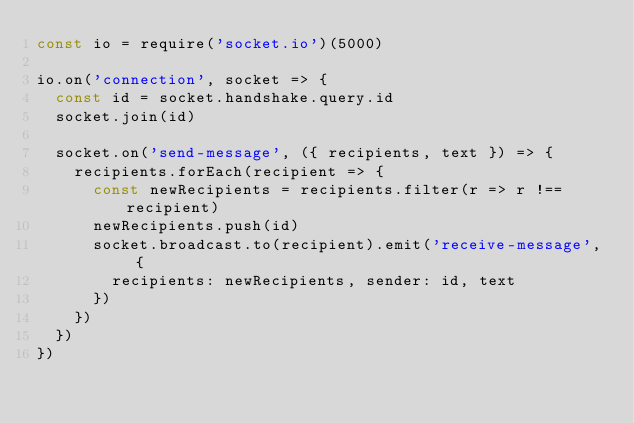<code> <loc_0><loc_0><loc_500><loc_500><_JavaScript_>const io = require('socket.io')(5000)

io.on('connection', socket => {
  const id = socket.handshake.query.id
  socket.join(id)

  socket.on('send-message', ({ recipients, text }) => {
    recipients.forEach(recipient => {
      const newRecipients = recipients.filter(r => r !== recipient)
      newRecipients.push(id)
      socket.broadcast.to(recipient).emit('receive-message', {
        recipients: newRecipients, sender: id, text
      })
    })
  })
})</code> 